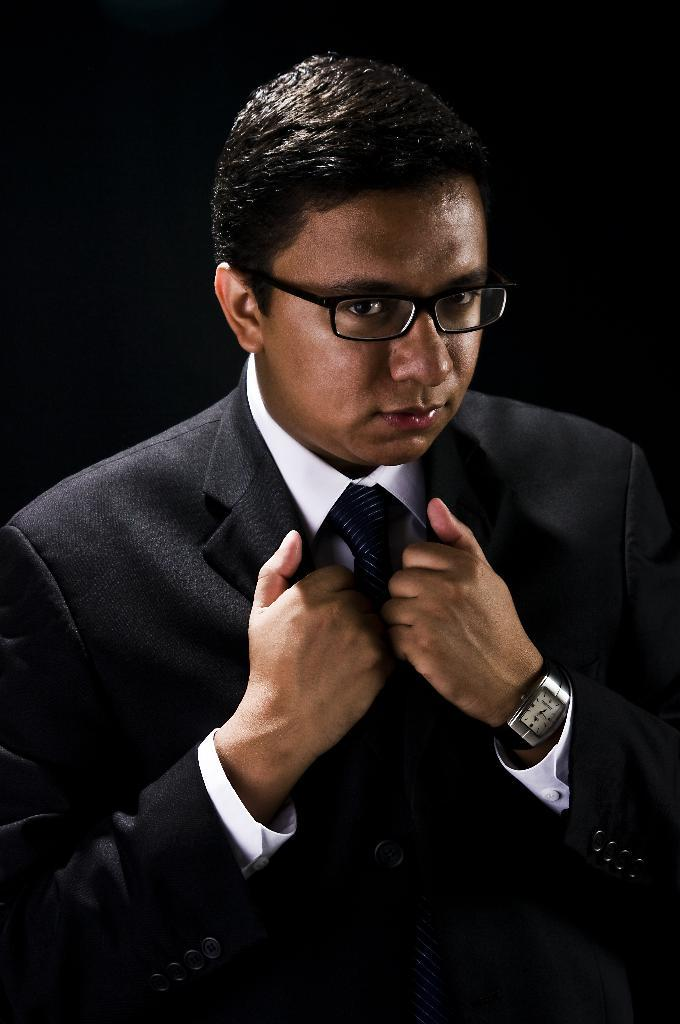Who is present in the image? There is a man in the image. What accessory is the man wearing? The man is wearing spectacles. What can be observed about the background of the image? The background of the image is dark. What type of receipt can be seen in the man's hand in the image? There is no receipt present in the image; the man is not holding anything. 